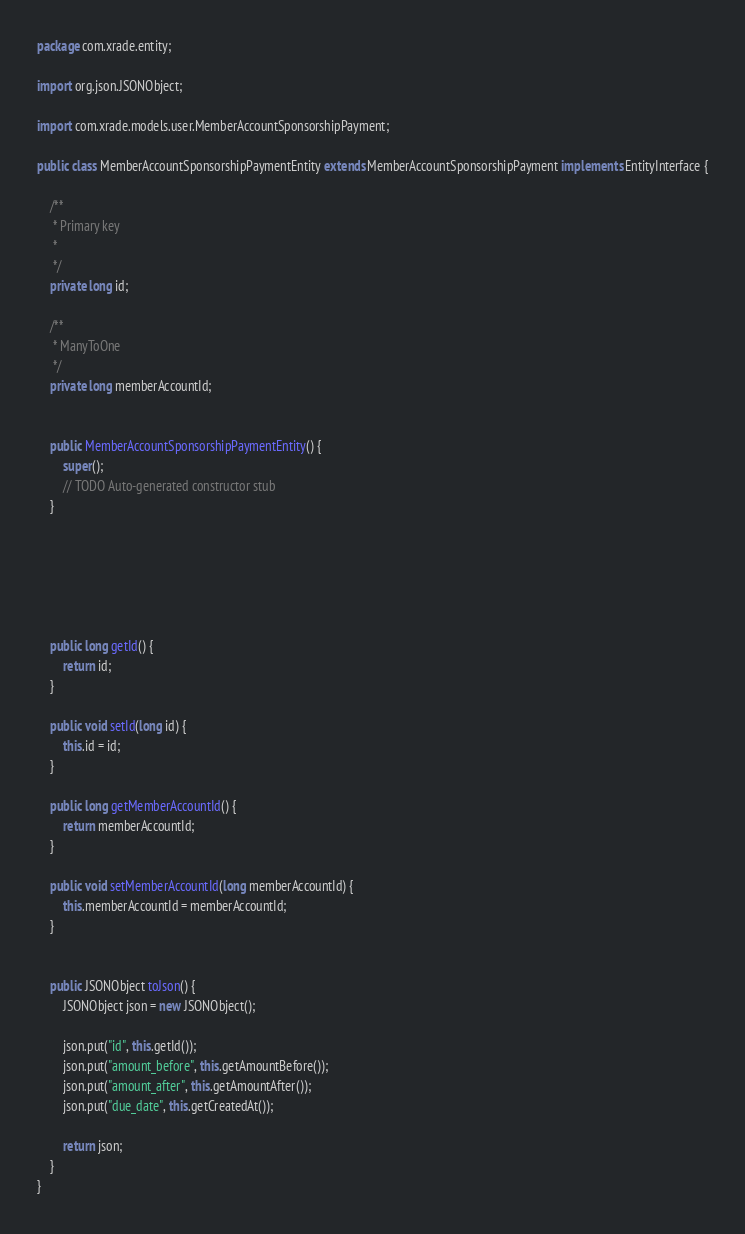<code> <loc_0><loc_0><loc_500><loc_500><_Java_>package com.xrade.entity;

import org.json.JSONObject;

import com.xrade.models.user.MemberAccountSponsorshipPayment;

public class MemberAccountSponsorshipPaymentEntity extends MemberAccountSponsorshipPayment implements EntityInterface {
	
	/**
	 * Primary key
	 * 
	 */
	private long id;
	
	/**
	 * ManyToOne
	 */
	private long memberAccountId;
	
	
	public MemberAccountSponsorshipPaymentEntity() {
		super();
		// TODO Auto-generated constructor stub
	}


	



	public long getId() {
		return id;
	}

	public void setId(long id) {
		this.id = id;
	}
	
	public long getMemberAccountId() {
		return memberAccountId;
	}

	public void setMemberAccountId(long memberAccountId) {
		this.memberAccountId = memberAccountId;
	}


	public JSONObject toJson() {
		JSONObject json = new JSONObject();
		
		json.put("id", this.getId());
		json.put("amount_before", this.getAmountBefore());
		json.put("amount_after", this.getAmountAfter());
		json.put("due_date", this.getCreatedAt());
		
		return json;
	}
}
</code> 